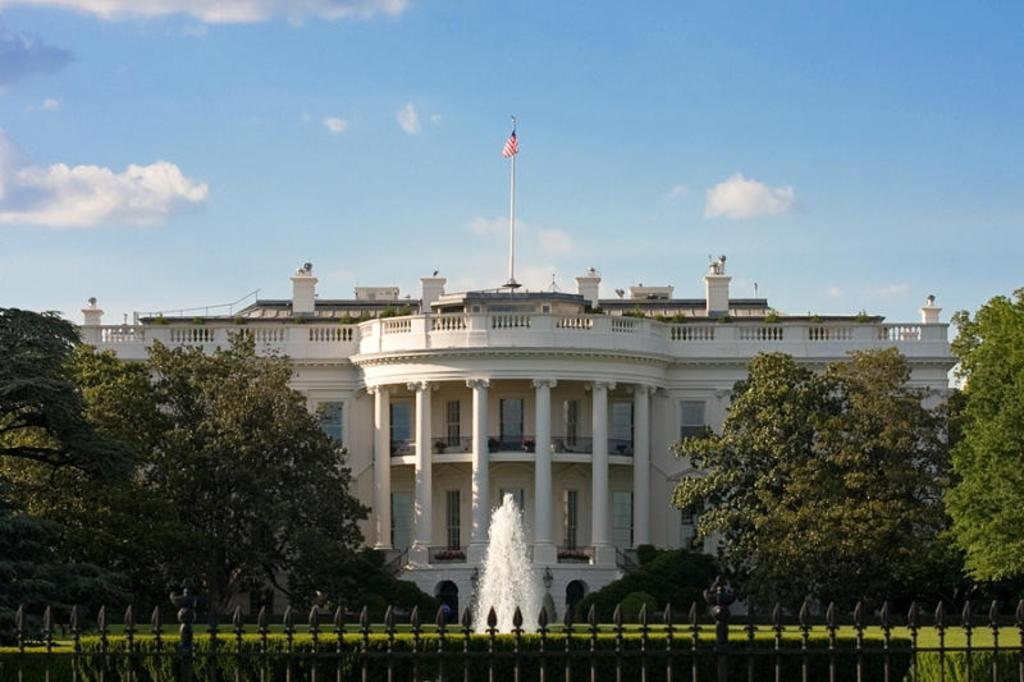What type of structure is visible in the image? There is a building in the image. What is the color of the building? The building is white. What is located in front of the building? There is a fountain in front of the building. What can be seen on either side of the building? There are trees to the left and right of the building. What is visible in the sky at the top of the image? There are clouds in the sky at the top of the image. Can you tell me how many horses are grazing in front of the building? There are no horses present in the image; it features a fountain in front of the building. What type of needle is being used to sew the clouds in the sky? There is no needle present in the image, and the clouds are not being sewn. 